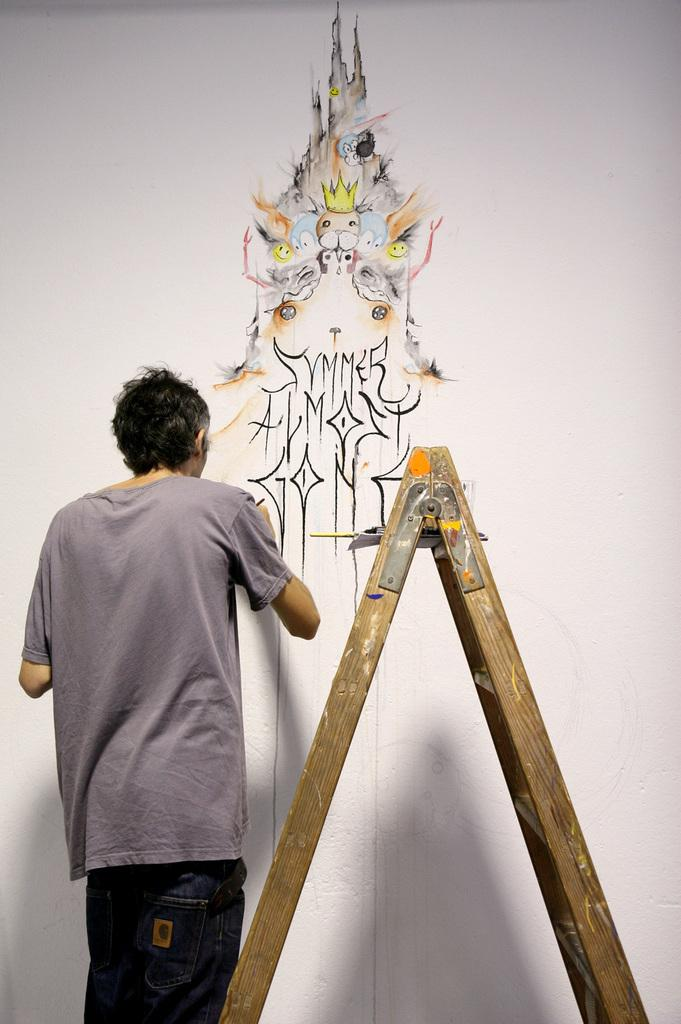What is the main subject of the image? There is a person standing in the image. What object is located in the middle of the image? There is a ladder in the middle of the image. What can be seen in the background of the image? There is a wall in the background of the image. What is on the wall in the background? There is a painting on the wall in the background. What type of bat is hanging from the ladder in the image? There is no bat present in the image; it only features a person, a ladder, a wall, and a painting. 